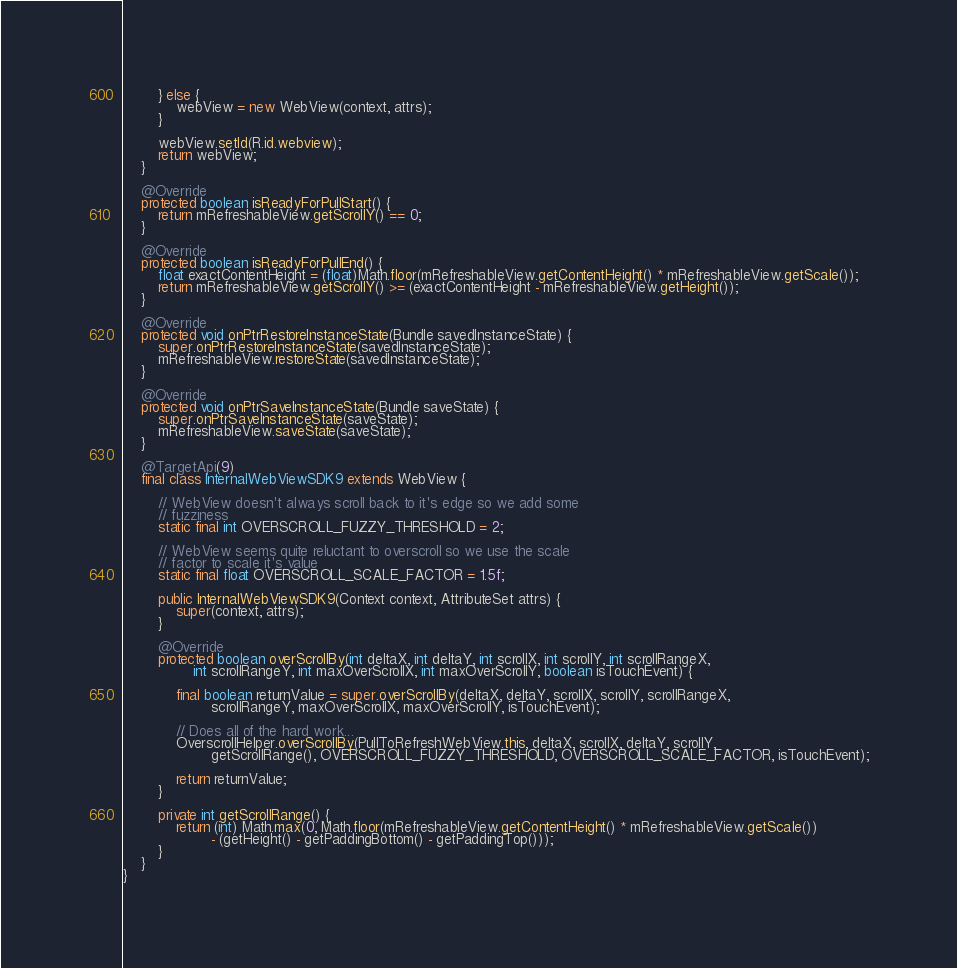Convert code to text. <code><loc_0><loc_0><loc_500><loc_500><_Java_>		} else {
			webView = new WebView(context, attrs);
		}

		webView.setId(R.id.webview);
		return webView;
	}

	@Override
	protected boolean isReadyForPullStart() {
		return mRefreshableView.getScrollY() == 0;
	}

	@Override
	protected boolean isReadyForPullEnd() {
		float exactContentHeight = (float)Math.floor(mRefreshableView.getContentHeight() * mRefreshableView.getScale());
		return mRefreshableView.getScrollY() >= (exactContentHeight - mRefreshableView.getHeight());
	}

	@Override
	protected void onPtrRestoreInstanceState(Bundle savedInstanceState) {
		super.onPtrRestoreInstanceState(savedInstanceState);
		mRefreshableView.restoreState(savedInstanceState);
	}

	@Override
	protected void onPtrSaveInstanceState(Bundle saveState) {
		super.onPtrSaveInstanceState(saveState);
		mRefreshableView.saveState(saveState);
	}

	@TargetApi(9)
	final class InternalWebViewSDK9 extends WebView {

		// WebView doesn't always scroll back to it's edge so we add some
		// fuzziness
		static final int OVERSCROLL_FUZZY_THRESHOLD = 2;

		// WebView seems quite reluctant to overscroll so we use the scale
		// factor to scale it's value
		static final float OVERSCROLL_SCALE_FACTOR = 1.5f;

		public InternalWebViewSDK9(Context context, AttributeSet attrs) {
			super(context, attrs);
		}

		@Override
		protected boolean overScrollBy(int deltaX, int deltaY, int scrollX, int scrollY, int scrollRangeX,
				int scrollRangeY, int maxOverScrollX, int maxOverScrollY, boolean isTouchEvent) {

			final boolean returnValue = super.overScrollBy(deltaX, deltaY, scrollX, scrollY, scrollRangeX,
					scrollRangeY, maxOverScrollX, maxOverScrollY, isTouchEvent);

			// Does all of the hard work...
			OverscrollHelper.overScrollBy(PullToRefreshWebView.this, deltaX, scrollX, deltaY, scrollY,
					getScrollRange(), OVERSCROLL_FUZZY_THRESHOLD, OVERSCROLL_SCALE_FACTOR, isTouchEvent);

			return returnValue;
		}

		private int getScrollRange() {
			return (int) Math.max(0, Math.floor(mRefreshableView.getContentHeight() * mRefreshableView.getScale())
					- (getHeight() - getPaddingBottom() - getPaddingTop()));
		}
	}
}
</code> 